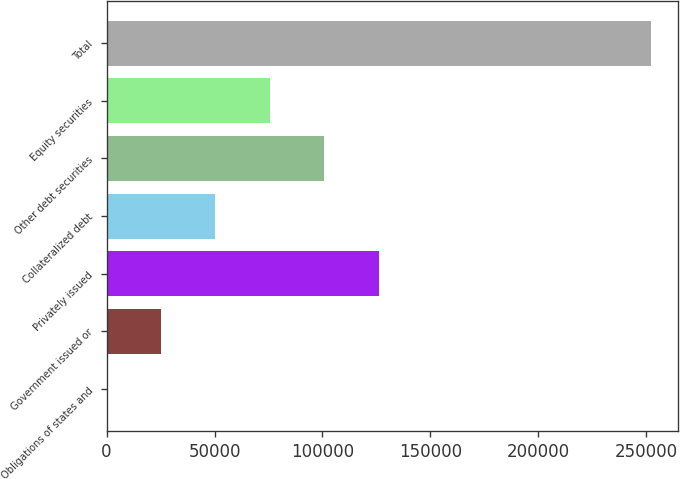Convert chart to OTSL. <chart><loc_0><loc_0><loc_500><loc_500><bar_chart><fcel>Obligations of states and<fcel>Government issued or<fcel>Privately issued<fcel>Collateralized debt<fcel>Other debt securities<fcel>Equity securities<fcel>Total<nl><fcel>8<fcel>25225.1<fcel>126094<fcel>50442.2<fcel>100876<fcel>75659.3<fcel>252179<nl></chart> 